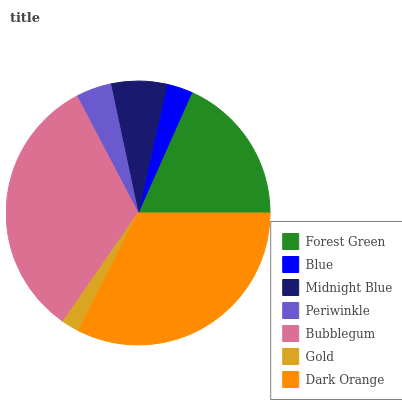Is Gold the minimum?
Answer yes or no. Yes. Is Bubblegum the maximum?
Answer yes or no. Yes. Is Blue the minimum?
Answer yes or no. No. Is Blue the maximum?
Answer yes or no. No. Is Forest Green greater than Blue?
Answer yes or no. Yes. Is Blue less than Forest Green?
Answer yes or no. Yes. Is Blue greater than Forest Green?
Answer yes or no. No. Is Forest Green less than Blue?
Answer yes or no. No. Is Midnight Blue the high median?
Answer yes or no. Yes. Is Midnight Blue the low median?
Answer yes or no. Yes. Is Gold the high median?
Answer yes or no. No. Is Bubblegum the low median?
Answer yes or no. No. 